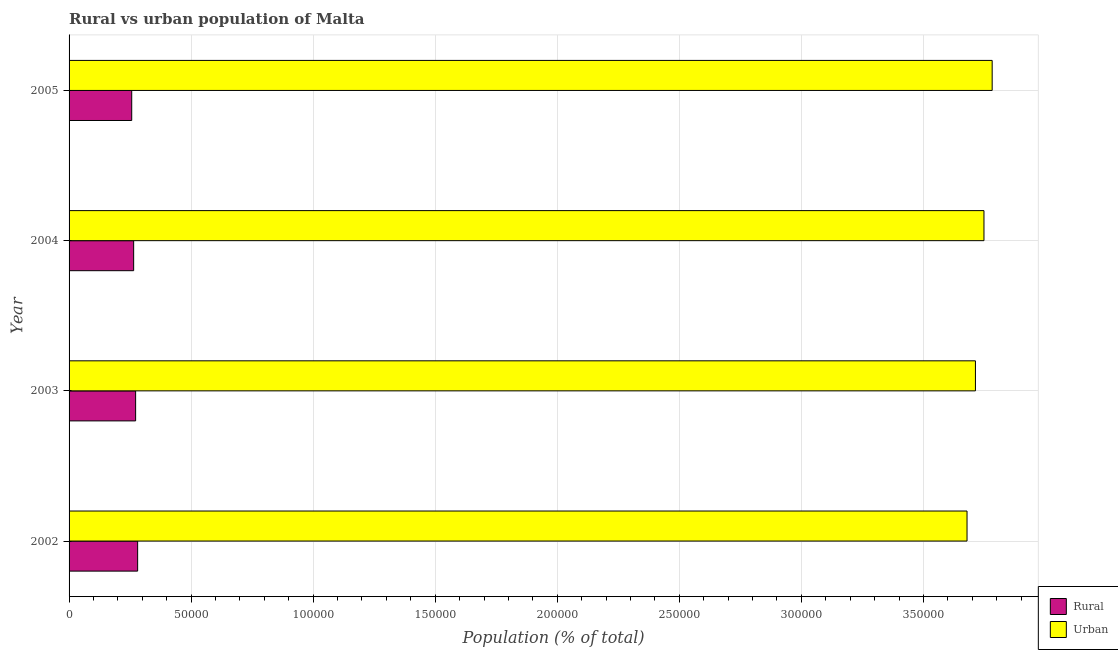How many different coloured bars are there?
Make the answer very short. 2. Are the number of bars on each tick of the Y-axis equal?
Offer a terse response. Yes. How many bars are there on the 1st tick from the top?
Make the answer very short. 2. What is the rural population density in 2005?
Ensure brevity in your answer.  2.57e+04. Across all years, what is the maximum urban population density?
Ensure brevity in your answer.  3.78e+05. Across all years, what is the minimum rural population density?
Your answer should be compact. 2.57e+04. In which year was the urban population density minimum?
Make the answer very short. 2002. What is the total rural population density in the graph?
Offer a terse response. 1.07e+05. What is the difference between the rural population density in 2002 and that in 2004?
Make the answer very short. 1638. What is the difference between the rural population density in 2002 and the urban population density in 2004?
Your answer should be compact. -3.47e+05. What is the average rural population density per year?
Keep it short and to the point. 2.69e+04. In the year 2003, what is the difference between the rural population density and urban population density?
Your answer should be compact. -3.44e+05. In how many years, is the rural population density greater than 230000 %?
Provide a short and direct response. 0. What is the ratio of the urban population density in 2003 to that in 2004?
Keep it short and to the point. 0.99. Is the urban population density in 2002 less than that in 2003?
Give a very brief answer. Yes. Is the difference between the urban population density in 2002 and 2005 greater than the difference between the rural population density in 2002 and 2005?
Make the answer very short. No. What is the difference between the highest and the second highest urban population density?
Your response must be concise. 3358. What is the difference between the highest and the lowest rural population density?
Offer a terse response. 2430. In how many years, is the rural population density greater than the average rural population density taken over all years?
Ensure brevity in your answer.  2. Is the sum of the urban population density in 2002 and 2003 greater than the maximum rural population density across all years?
Keep it short and to the point. Yes. What does the 1st bar from the top in 2003 represents?
Your answer should be compact. Urban. What does the 2nd bar from the bottom in 2003 represents?
Your answer should be compact. Urban. How many bars are there?
Give a very brief answer. 8. Are all the bars in the graph horizontal?
Your answer should be compact. Yes. How many years are there in the graph?
Offer a very short reply. 4. What is the difference between two consecutive major ticks on the X-axis?
Give a very brief answer. 5.00e+04. How many legend labels are there?
Offer a very short reply. 2. What is the title of the graph?
Your response must be concise. Rural vs urban population of Malta. Does "Money lenders" appear as one of the legend labels in the graph?
Your answer should be compact. No. What is the label or title of the X-axis?
Your response must be concise. Population (% of total). What is the label or title of the Y-axis?
Ensure brevity in your answer.  Year. What is the Population (% of total) in Rural in 2002?
Provide a succinct answer. 2.81e+04. What is the Population (% of total) of Urban in 2002?
Provide a short and direct response. 3.68e+05. What is the Population (% of total) in Rural in 2003?
Give a very brief answer. 2.73e+04. What is the Population (% of total) of Urban in 2003?
Offer a terse response. 3.71e+05. What is the Population (% of total) of Rural in 2004?
Make the answer very short. 2.65e+04. What is the Population (% of total) of Urban in 2004?
Your answer should be very brief. 3.75e+05. What is the Population (% of total) of Rural in 2005?
Give a very brief answer. 2.57e+04. What is the Population (% of total) in Urban in 2005?
Offer a terse response. 3.78e+05. Across all years, what is the maximum Population (% of total) of Rural?
Your answer should be compact. 2.81e+04. Across all years, what is the maximum Population (% of total) in Urban?
Your answer should be compact. 3.78e+05. Across all years, what is the minimum Population (% of total) in Rural?
Keep it short and to the point. 2.57e+04. Across all years, what is the minimum Population (% of total) of Urban?
Provide a short and direct response. 3.68e+05. What is the total Population (% of total) of Rural in the graph?
Your answer should be very brief. 1.07e+05. What is the total Population (% of total) in Urban in the graph?
Your answer should be very brief. 1.49e+06. What is the difference between the Population (% of total) of Rural in 2002 and that in 2003?
Your response must be concise. 831. What is the difference between the Population (% of total) in Urban in 2002 and that in 2003?
Give a very brief answer. -3444. What is the difference between the Population (% of total) of Rural in 2002 and that in 2004?
Provide a succinct answer. 1638. What is the difference between the Population (% of total) in Urban in 2002 and that in 2004?
Offer a terse response. -6937. What is the difference between the Population (% of total) of Rural in 2002 and that in 2005?
Provide a succinct answer. 2430. What is the difference between the Population (% of total) in Urban in 2002 and that in 2005?
Provide a short and direct response. -1.03e+04. What is the difference between the Population (% of total) in Rural in 2003 and that in 2004?
Ensure brevity in your answer.  807. What is the difference between the Population (% of total) in Urban in 2003 and that in 2004?
Keep it short and to the point. -3493. What is the difference between the Population (% of total) in Rural in 2003 and that in 2005?
Offer a very short reply. 1599. What is the difference between the Population (% of total) of Urban in 2003 and that in 2005?
Your response must be concise. -6851. What is the difference between the Population (% of total) of Rural in 2004 and that in 2005?
Offer a very short reply. 792. What is the difference between the Population (% of total) in Urban in 2004 and that in 2005?
Ensure brevity in your answer.  -3358. What is the difference between the Population (% of total) of Rural in 2002 and the Population (% of total) of Urban in 2003?
Keep it short and to the point. -3.43e+05. What is the difference between the Population (% of total) of Rural in 2002 and the Population (% of total) of Urban in 2004?
Keep it short and to the point. -3.47e+05. What is the difference between the Population (% of total) in Rural in 2002 and the Population (% of total) in Urban in 2005?
Make the answer very short. -3.50e+05. What is the difference between the Population (% of total) of Rural in 2003 and the Population (% of total) of Urban in 2004?
Make the answer very short. -3.48e+05. What is the difference between the Population (% of total) in Rural in 2003 and the Population (% of total) in Urban in 2005?
Give a very brief answer. -3.51e+05. What is the difference between the Population (% of total) of Rural in 2004 and the Population (% of total) of Urban in 2005?
Ensure brevity in your answer.  -3.52e+05. What is the average Population (% of total) in Rural per year?
Offer a terse response. 2.69e+04. What is the average Population (% of total) of Urban per year?
Offer a very short reply. 3.73e+05. In the year 2002, what is the difference between the Population (% of total) in Rural and Population (% of total) in Urban?
Your answer should be very brief. -3.40e+05. In the year 2003, what is the difference between the Population (% of total) in Rural and Population (% of total) in Urban?
Provide a short and direct response. -3.44e+05. In the year 2004, what is the difference between the Population (% of total) of Rural and Population (% of total) of Urban?
Offer a very short reply. -3.48e+05. In the year 2005, what is the difference between the Population (% of total) of Rural and Population (% of total) of Urban?
Your response must be concise. -3.53e+05. What is the ratio of the Population (% of total) of Rural in 2002 to that in 2003?
Your answer should be very brief. 1.03. What is the ratio of the Population (% of total) in Rural in 2002 to that in 2004?
Make the answer very short. 1.06. What is the ratio of the Population (% of total) in Urban in 2002 to that in 2004?
Offer a very short reply. 0.98. What is the ratio of the Population (% of total) in Rural in 2002 to that in 2005?
Make the answer very short. 1.09. What is the ratio of the Population (% of total) of Urban in 2002 to that in 2005?
Offer a terse response. 0.97. What is the ratio of the Population (% of total) in Rural in 2003 to that in 2004?
Offer a very short reply. 1.03. What is the ratio of the Population (% of total) in Rural in 2003 to that in 2005?
Your answer should be compact. 1.06. What is the ratio of the Population (% of total) of Urban in 2003 to that in 2005?
Offer a terse response. 0.98. What is the ratio of the Population (% of total) of Rural in 2004 to that in 2005?
Give a very brief answer. 1.03. What is the ratio of the Population (% of total) in Urban in 2004 to that in 2005?
Keep it short and to the point. 0.99. What is the difference between the highest and the second highest Population (% of total) in Rural?
Your answer should be compact. 831. What is the difference between the highest and the second highest Population (% of total) of Urban?
Ensure brevity in your answer.  3358. What is the difference between the highest and the lowest Population (% of total) in Rural?
Ensure brevity in your answer.  2430. What is the difference between the highest and the lowest Population (% of total) in Urban?
Keep it short and to the point. 1.03e+04. 